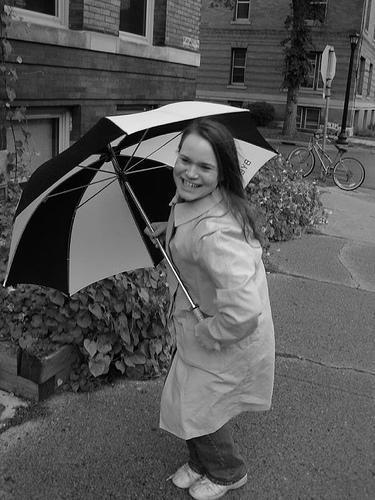How many people are under the umbrella?
Give a very brief answer. 1. 